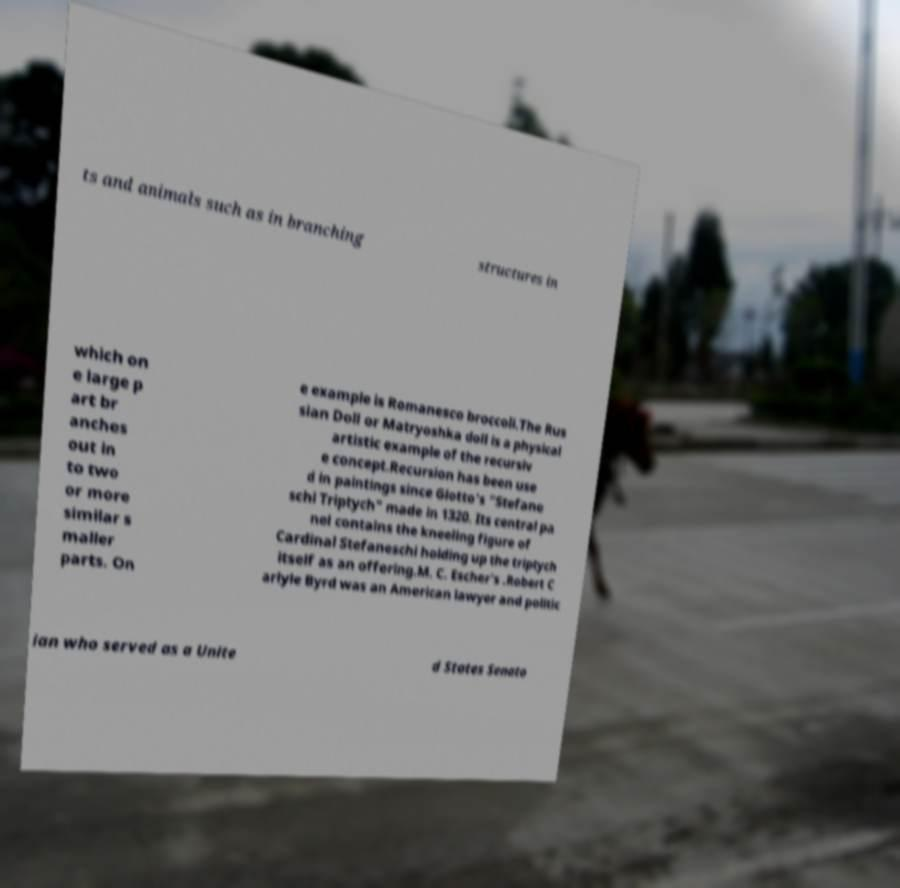What messages or text are displayed in this image? I need them in a readable, typed format. ts and animals such as in branching structures in which on e large p art br anches out in to two or more similar s maller parts. On e example is Romanesco broccoli.The Rus sian Doll or Matryoshka doll is a physical artistic example of the recursiv e concept.Recursion has been use d in paintings since Giotto's "Stefane schi Triptych" made in 1320. Its central pa nel contains the kneeling figure of Cardinal Stefaneschi holding up the triptych itself as an offering.M. C. Escher's .Robert C arlyle Byrd was an American lawyer and politic ian who served as a Unite d States Senato 